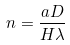<formula> <loc_0><loc_0><loc_500><loc_500>n = \frac { a D } { H \lambda }</formula> 